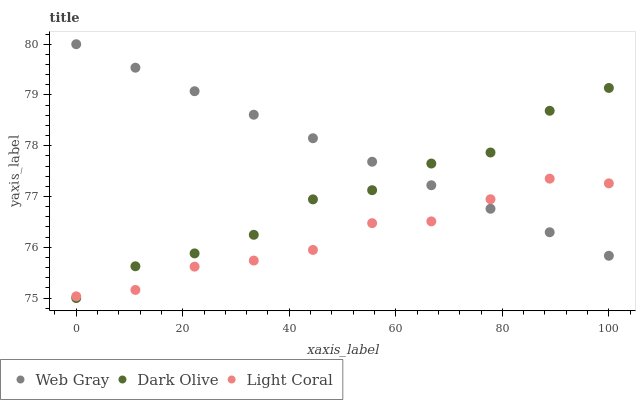Does Light Coral have the minimum area under the curve?
Answer yes or no. Yes. Does Web Gray have the maximum area under the curve?
Answer yes or no. Yes. Does Web Gray have the minimum area under the curve?
Answer yes or no. No. Does Light Coral have the maximum area under the curve?
Answer yes or no. No. Is Web Gray the smoothest?
Answer yes or no. Yes. Is Dark Olive the roughest?
Answer yes or no. Yes. Is Light Coral the smoothest?
Answer yes or no. No. Is Light Coral the roughest?
Answer yes or no. No. Does Dark Olive have the lowest value?
Answer yes or no. Yes. Does Light Coral have the lowest value?
Answer yes or no. No. Does Web Gray have the highest value?
Answer yes or no. Yes. Does Light Coral have the highest value?
Answer yes or no. No. Does Dark Olive intersect Web Gray?
Answer yes or no. Yes. Is Dark Olive less than Web Gray?
Answer yes or no. No. Is Dark Olive greater than Web Gray?
Answer yes or no. No. 